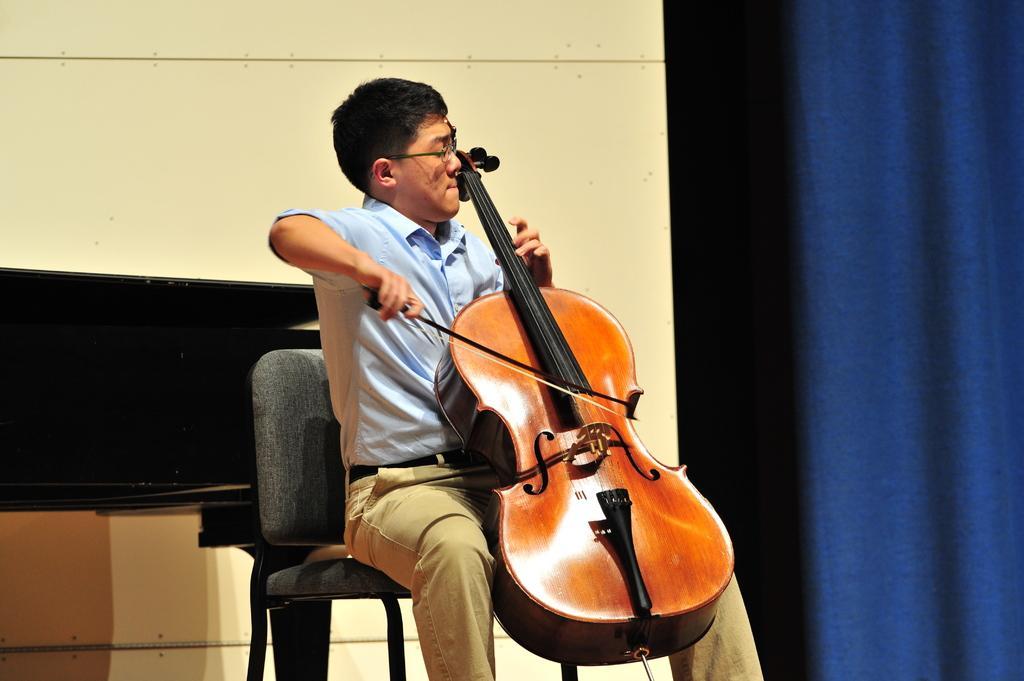Please provide a concise description of this image. In the middle of the image a man is sitting and playing violin. Right side of the image there is a curtain. Top left side of the image there is a wall. 